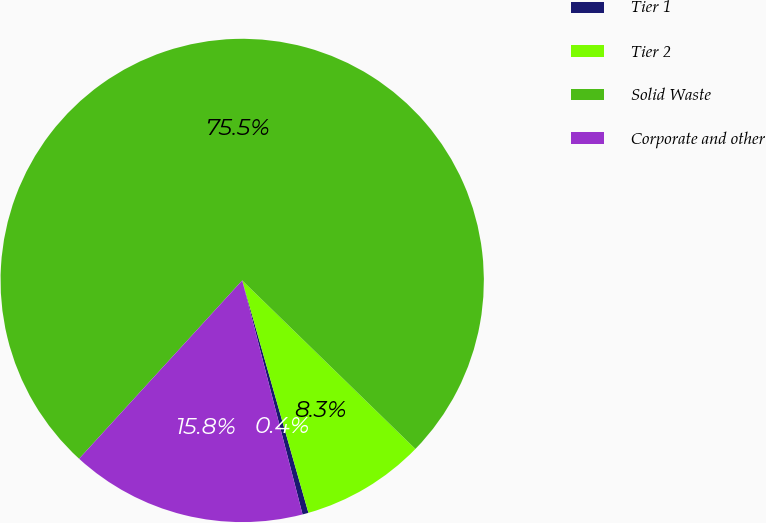Convert chart. <chart><loc_0><loc_0><loc_500><loc_500><pie_chart><fcel>Tier 1<fcel>Tier 2<fcel>Solid Waste<fcel>Corporate and other<nl><fcel>0.4%<fcel>8.3%<fcel>75.49%<fcel>15.81%<nl></chart> 